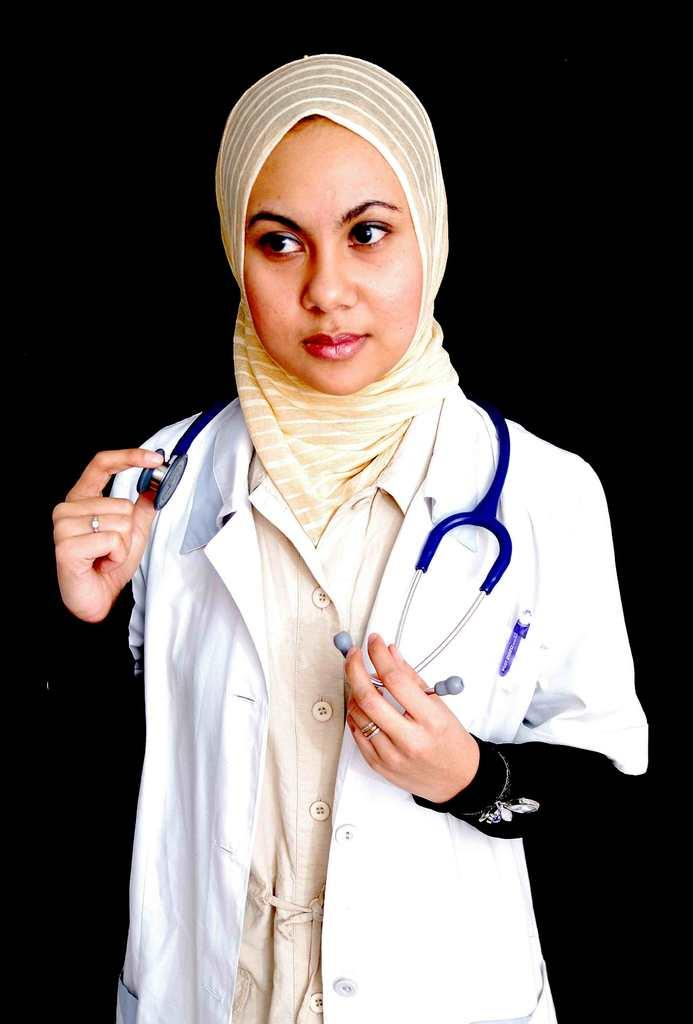What is the main subject of the image? There is a person in the image. What object can be seen with the person? There is a stethoscope in the image. What can be said about the background of the image? The background of the image is dark. How many bricks are visible in the image? There are no bricks present in the image. What is the value of the cent in the image? There is no cent present in the image. 